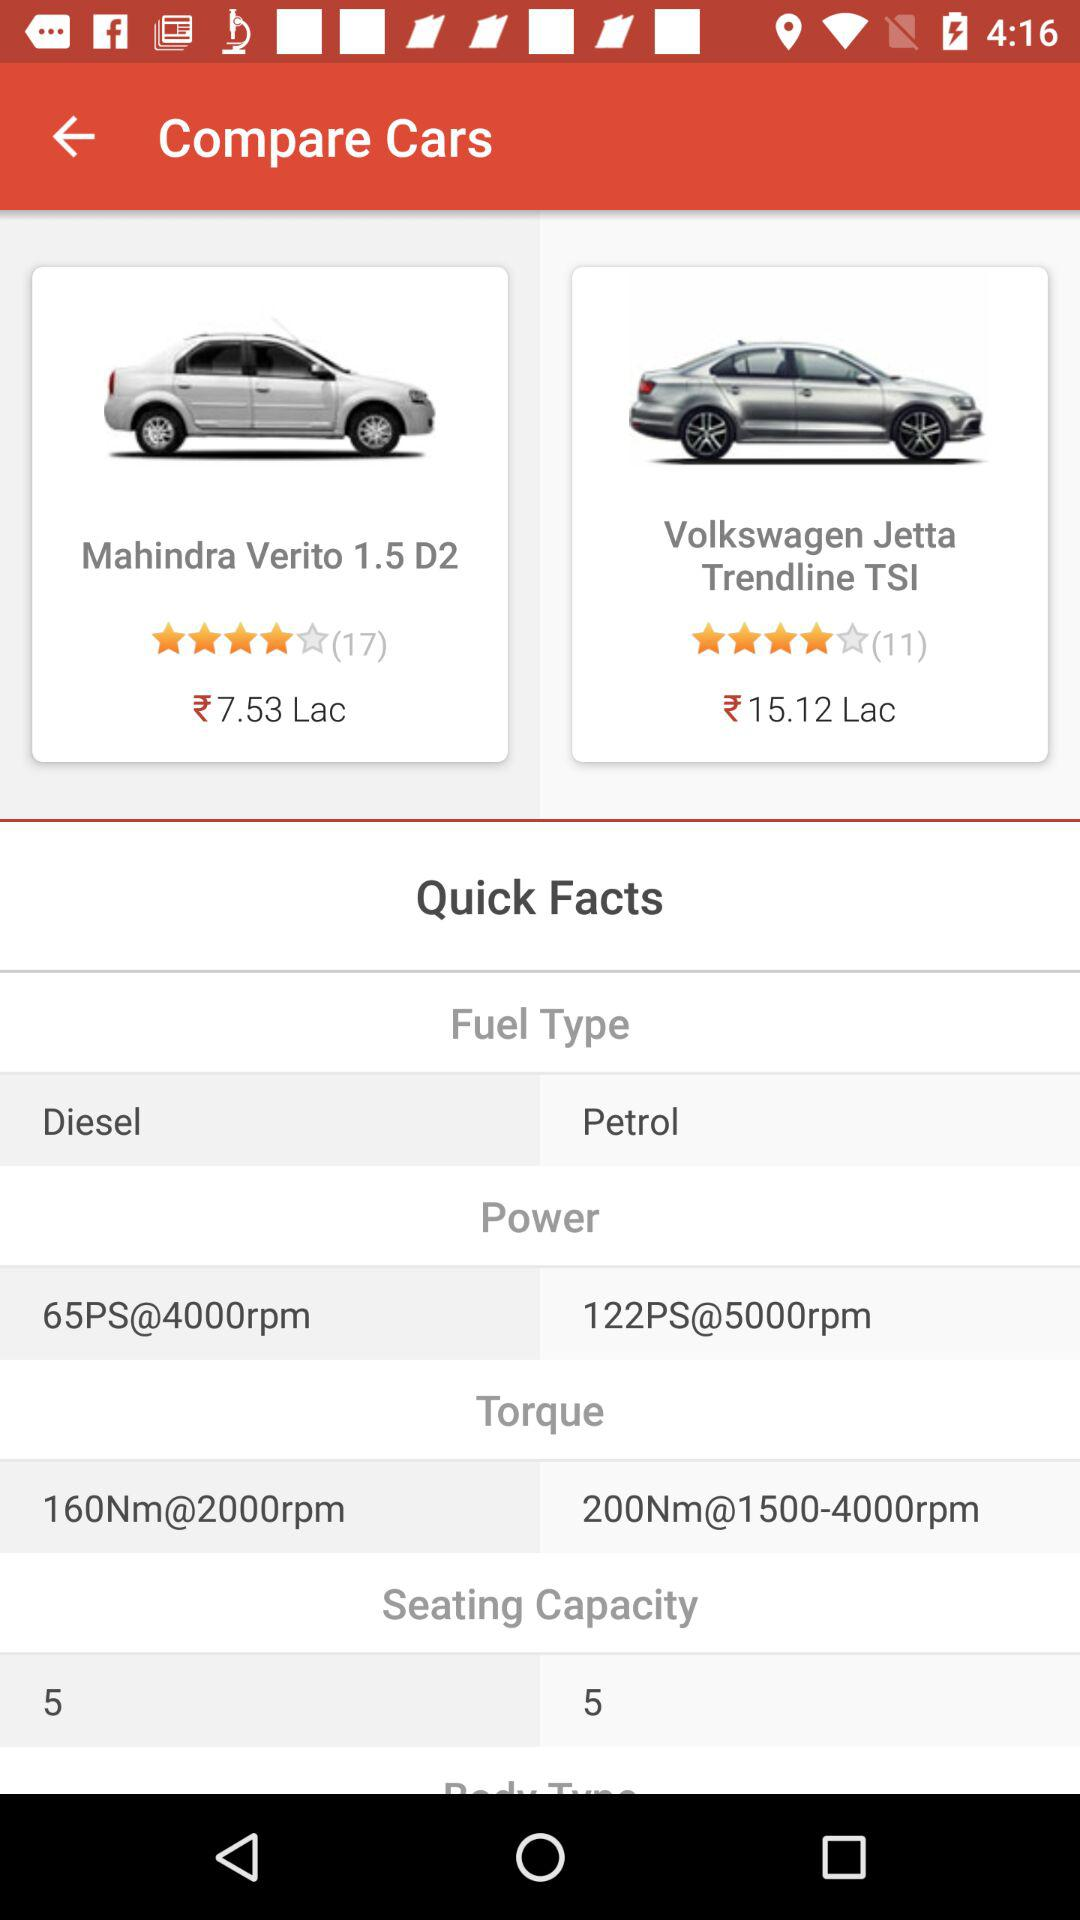Which car has the higher power?
Answer the question using a single word or phrase. Volkswagen Jetta Trendline TSI 